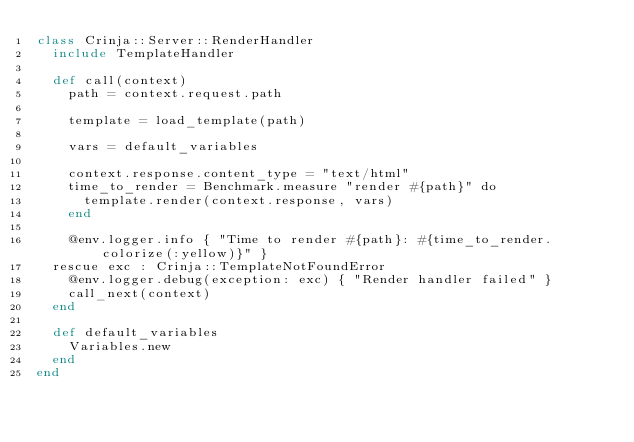Convert code to text. <code><loc_0><loc_0><loc_500><loc_500><_Crystal_>class Crinja::Server::RenderHandler
  include TemplateHandler

  def call(context)
    path = context.request.path

    template = load_template(path)

    vars = default_variables

    context.response.content_type = "text/html"
    time_to_render = Benchmark.measure "render #{path}" do
      template.render(context.response, vars)
    end

    @env.logger.info { "Time to render #{path}: #{time_to_render.colorize(:yellow)}" }
  rescue exc : Crinja::TemplateNotFoundError
    @env.logger.debug(exception: exc) { "Render handler failed" }
    call_next(context)
  end

  def default_variables
    Variables.new
  end
end
</code> 